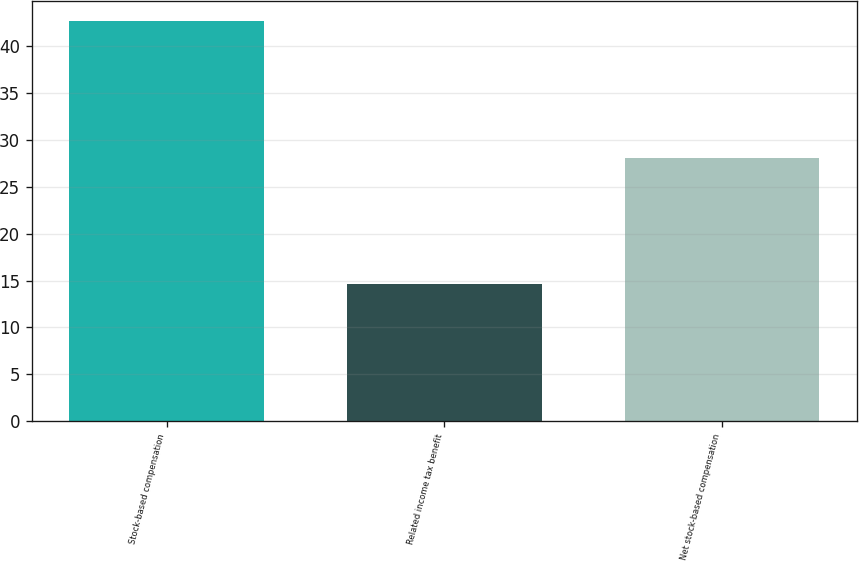<chart> <loc_0><loc_0><loc_500><loc_500><bar_chart><fcel>Stock-based compensation<fcel>Related income tax benefit<fcel>Net stock-based compensation<nl><fcel>42.7<fcel>14.6<fcel>28.1<nl></chart> 